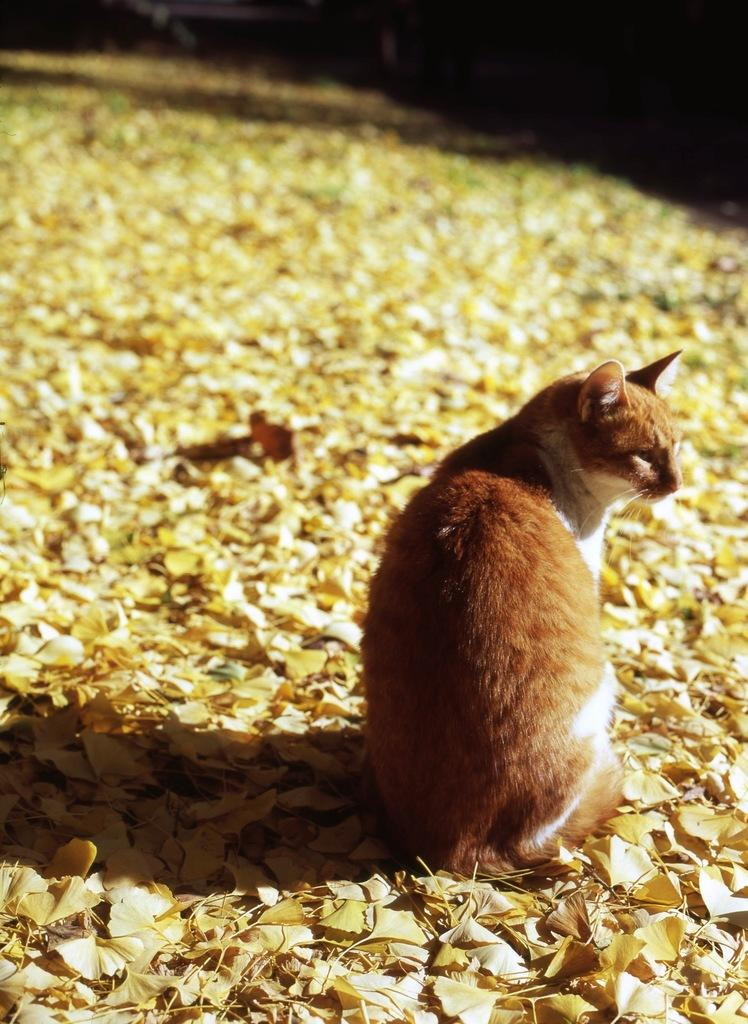What type of animal is in the image? There is a cat in the image. Where is the cat sitting? The cat is sitting on leaves. Is the queen swimming in the image? There is no queen or swimming activity present in the image. 